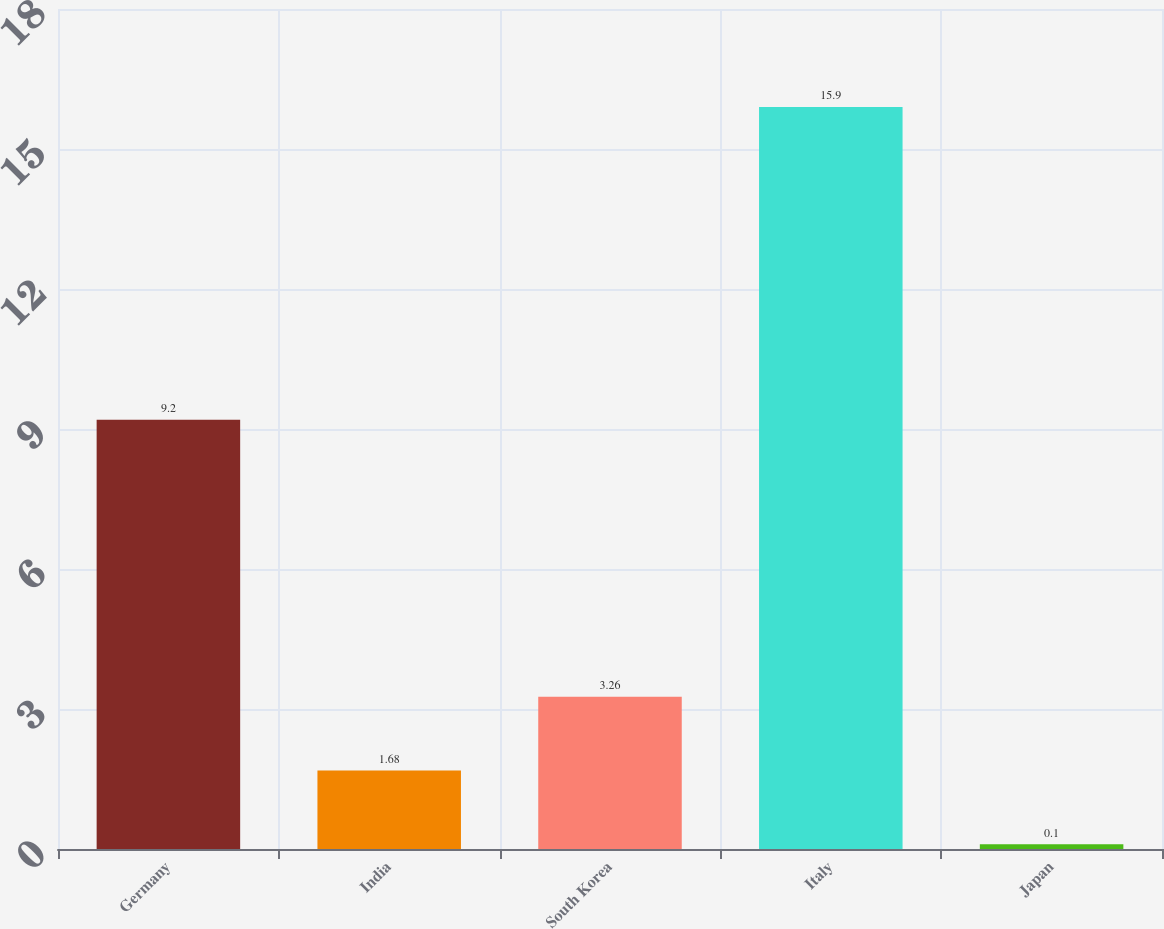<chart> <loc_0><loc_0><loc_500><loc_500><bar_chart><fcel>Germany<fcel>India<fcel>South Korea<fcel>Italy<fcel>Japan<nl><fcel>9.2<fcel>1.68<fcel>3.26<fcel>15.9<fcel>0.1<nl></chart> 